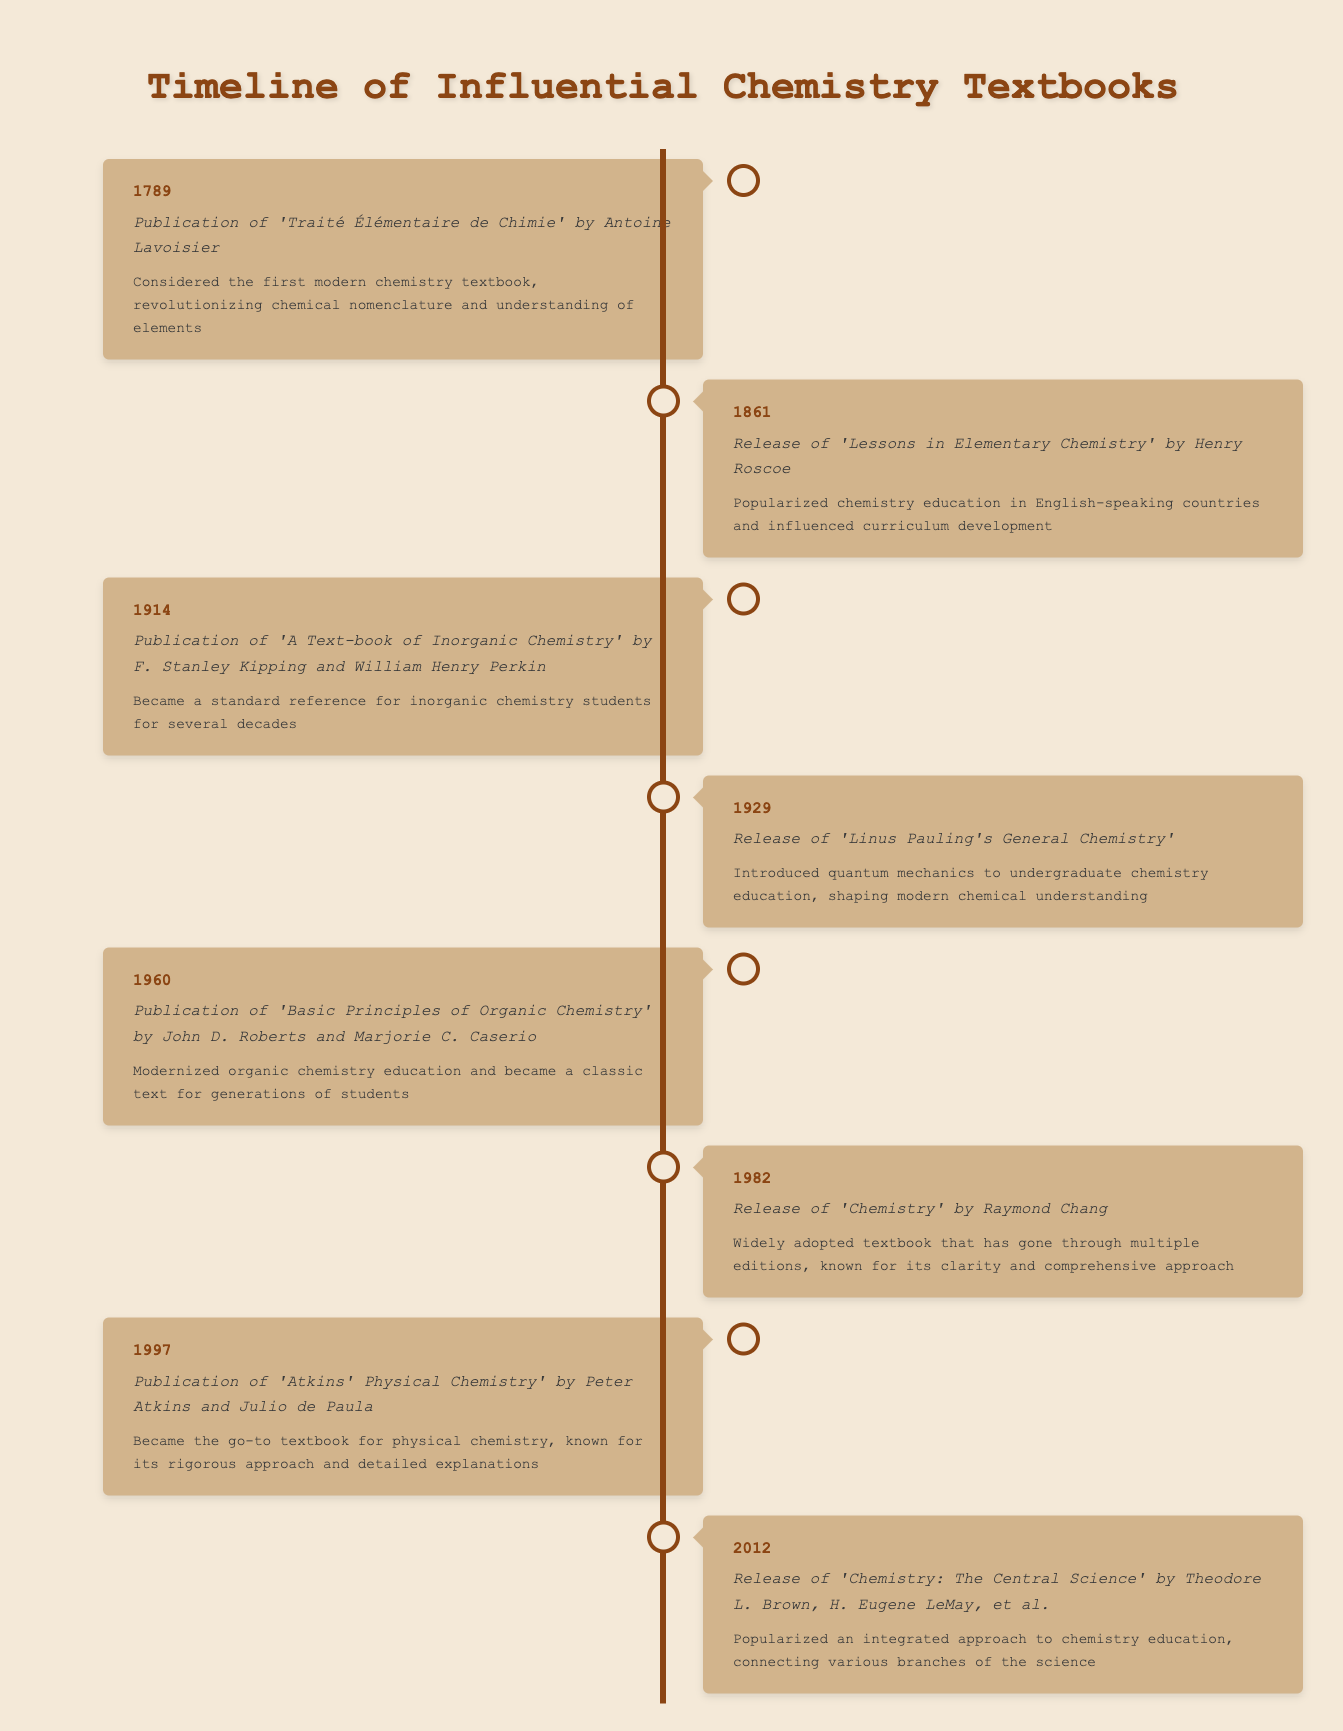What is the publication year of 'Chemistry: The Central Science'? The table lists 'Chemistry: The Central Science' released in 2012.
Answer: 2012 Which textbook was published first: 'Traité Élémentaire de Chimie' or 'Lessons in Elementary Chemistry'? 'Traité Élémentaire de Chimie' was published in 1789, whereas 'Lessons in Elementary Chemistry' was published in 1861, making the former the first one.
Answer: 'Traité Élémentaire de Chimie' What is the impact of Linus Pauling's General Chemistry? Linus Pauling's 'General Chemistry' is noted for introducing quantum mechanics to undergraduate chemistry education, which shaped modern chemical understanding.
Answer: Introduced quantum mechanics to undergraduate chemistry education How many years apart were the publications of 'Basic Principles of Organic Chemistry' and 'Chemistry'? 'Basic Principles of Organic Chemistry' was published in 1960 and 'Chemistry' in 1982. The difference is 1982 - 1960 = 22 years.
Answer: 22 years Is 'Atkins' Physical Chemistry' considered the go-to textbook for physical chemistry? Yes, according to the table, 'Atkins' Physical Chemistry' is described as the go-to textbook for the subject.
Answer: Yes Which textbook had a significant influence on curriculum development in English-speaking countries? 'Lessons in Elementary Chemistry' by Henry Roscoe is mentioned as having popularized chemistry education and influenced curriculum development.
Answer: Lessons in Elementary Chemistry How many textbooks were published before 1900? There are three textbooks listed (1789, 1861, and 1914) that fall before 1900: 'Traité Élémentaire de Chimie', 'Lessons in Elementary Chemistry', and 'A Text-book of Inorganic Chemistry'.
Answer: 2 Which textbook (if any) is recognized for modernizing organic chemistry education? 'Basic Principles of Organic Chemistry' by John D. Roberts and Marjorie C. Caserio is recognized for modernizing organic chemistry education.
Answer: Basic Principles of Organic Chemistry What would be a good summary impact statement for 'Chemistry: The Central Science'? 'Chemistry: The Central Science' is known for popularizing an integrated approach to chemistry education, connecting various branches of the science.
Answer: Integrated approach to chemistry education 